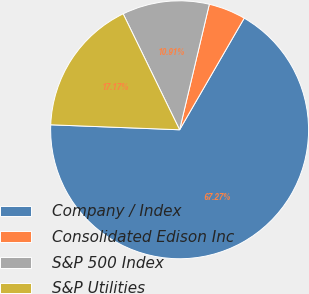<chart> <loc_0><loc_0><loc_500><loc_500><pie_chart><fcel>Company / Index<fcel>Consolidated Edison Inc<fcel>S&P 500 Index<fcel>S&P Utilities<nl><fcel>67.26%<fcel>4.65%<fcel>10.91%<fcel>17.17%<nl></chart> 